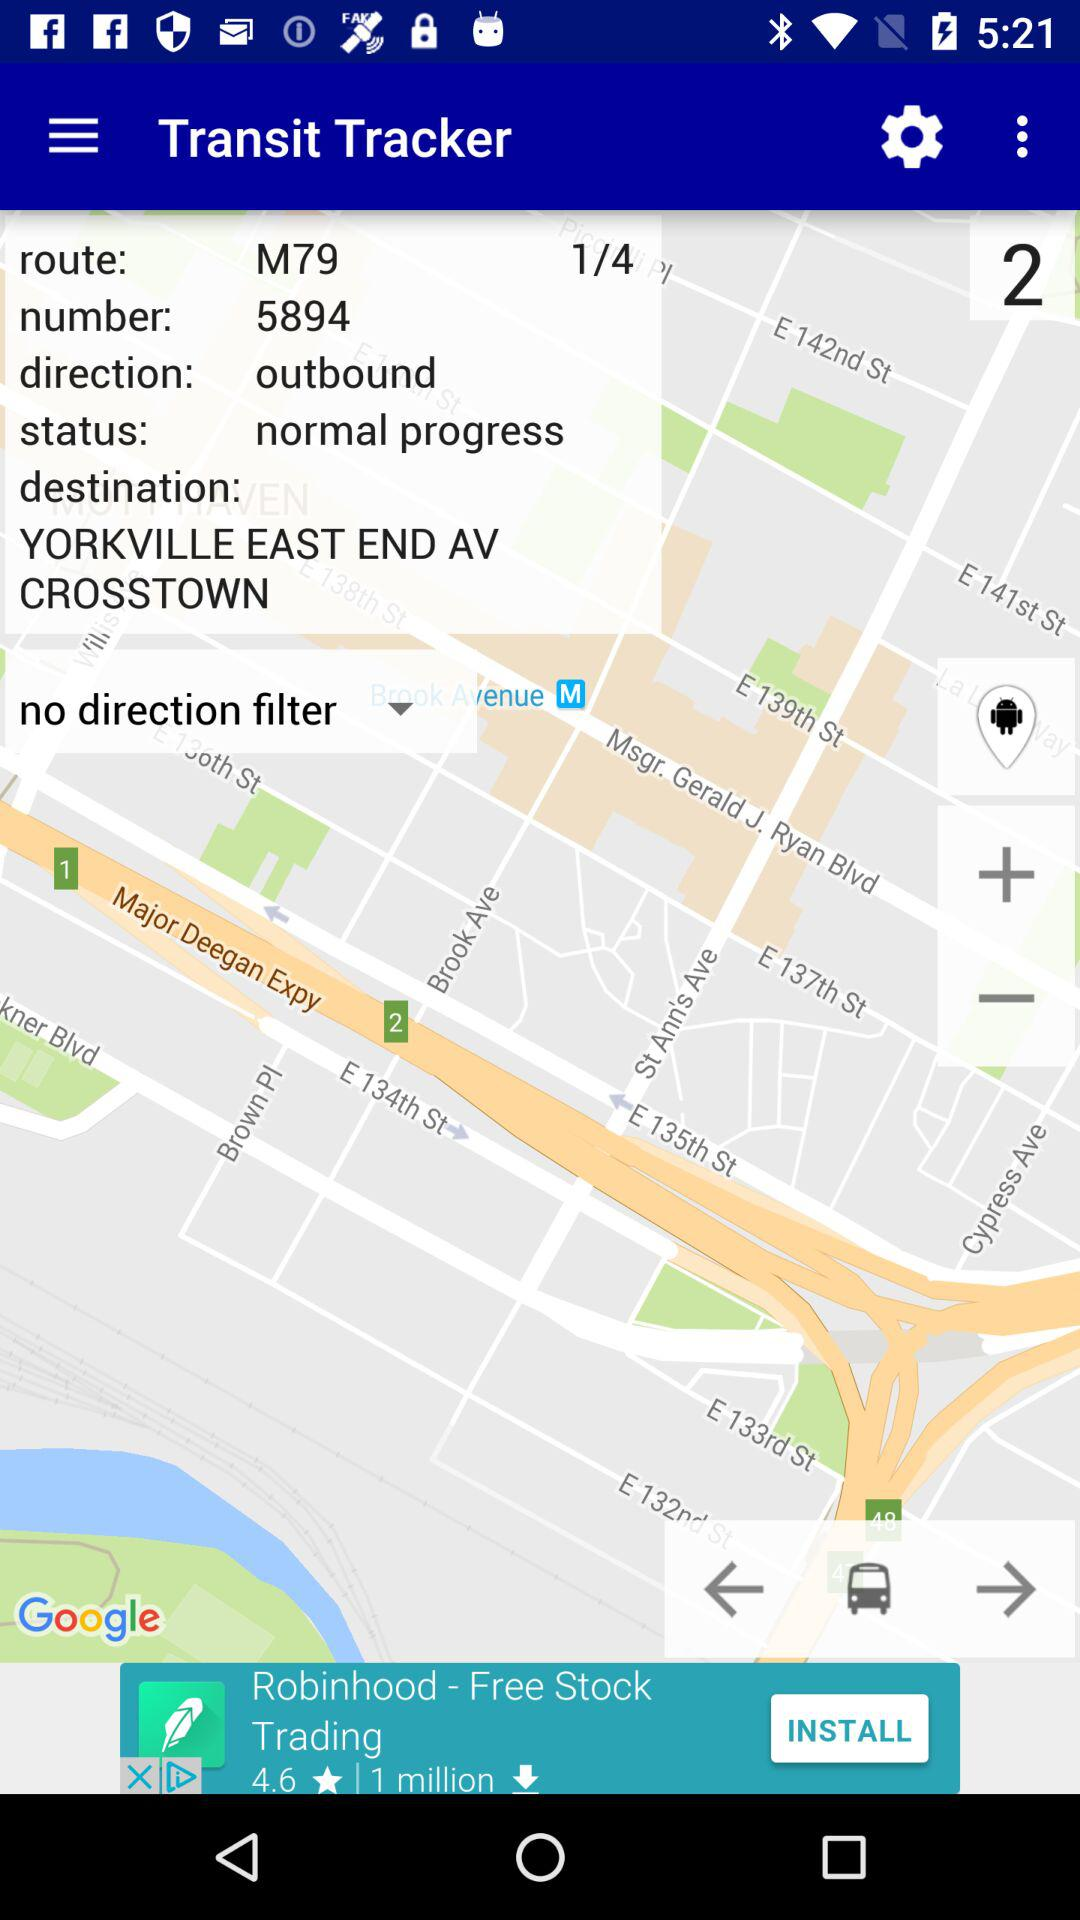What is the number of the tracker? The number of the tracker is 5894. 